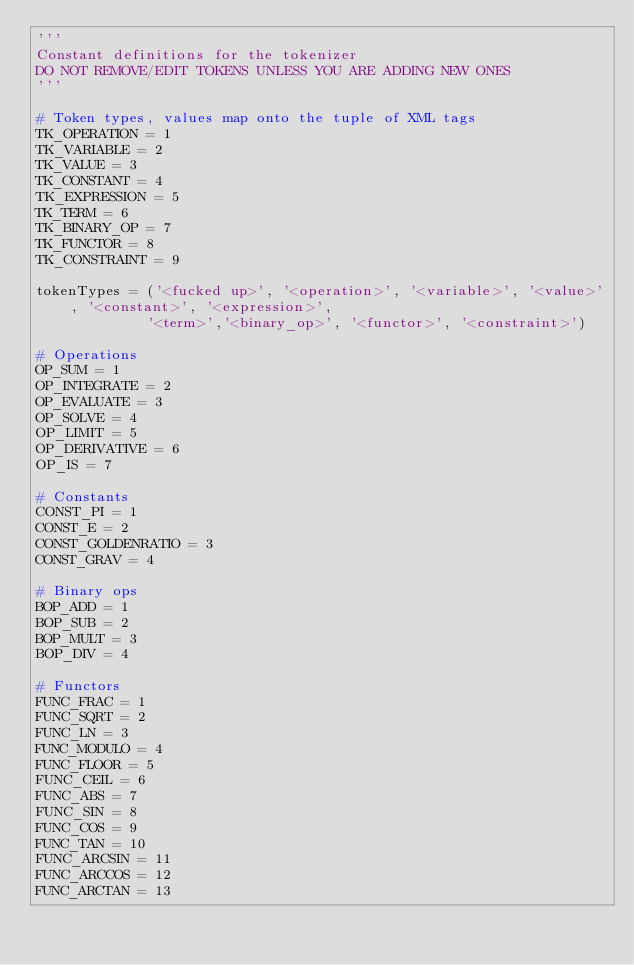<code> <loc_0><loc_0><loc_500><loc_500><_Python_>'''
Constant definitions for the tokenizer
DO NOT REMOVE/EDIT TOKENS UNLESS YOU ARE ADDING NEW ONES
'''

# Token types, values map onto the tuple of XML tags
TK_OPERATION = 1
TK_VARIABLE = 2
TK_VALUE = 3
TK_CONSTANT = 4
TK_EXPRESSION = 5
TK_TERM = 6
TK_BINARY_OP = 7
TK_FUNCTOR = 8
TK_CONSTRAINT = 9

tokenTypes = ('<fucked up>', '<operation>', '<variable>', '<value>', '<constant>', '<expression>',
             '<term>','<binary_op>', '<functor>', '<constraint>')

# Operations
OP_SUM = 1
OP_INTEGRATE = 2
OP_EVALUATE = 3
OP_SOLVE = 4
OP_LIMIT = 5
OP_DERIVATIVE = 6
OP_IS = 7

# Constants
CONST_PI = 1
CONST_E = 2
CONST_GOLDENRATIO = 3
CONST_GRAV = 4

# Binary ops
BOP_ADD = 1
BOP_SUB = 2
BOP_MULT = 3
BOP_DIV = 4

# Functors
FUNC_FRAC = 1
FUNC_SQRT = 2
FUNC_LN = 3
FUNC_MODULO = 4
FUNC_FLOOR = 5
FUNC_CEIL = 6
FUNC_ABS = 7
FUNC_SIN = 8
FUNC_COS = 9
FUNC_TAN = 10
FUNC_ARCSIN = 11
FUNC_ARCCOS = 12
FUNC_ARCTAN = 13</code> 